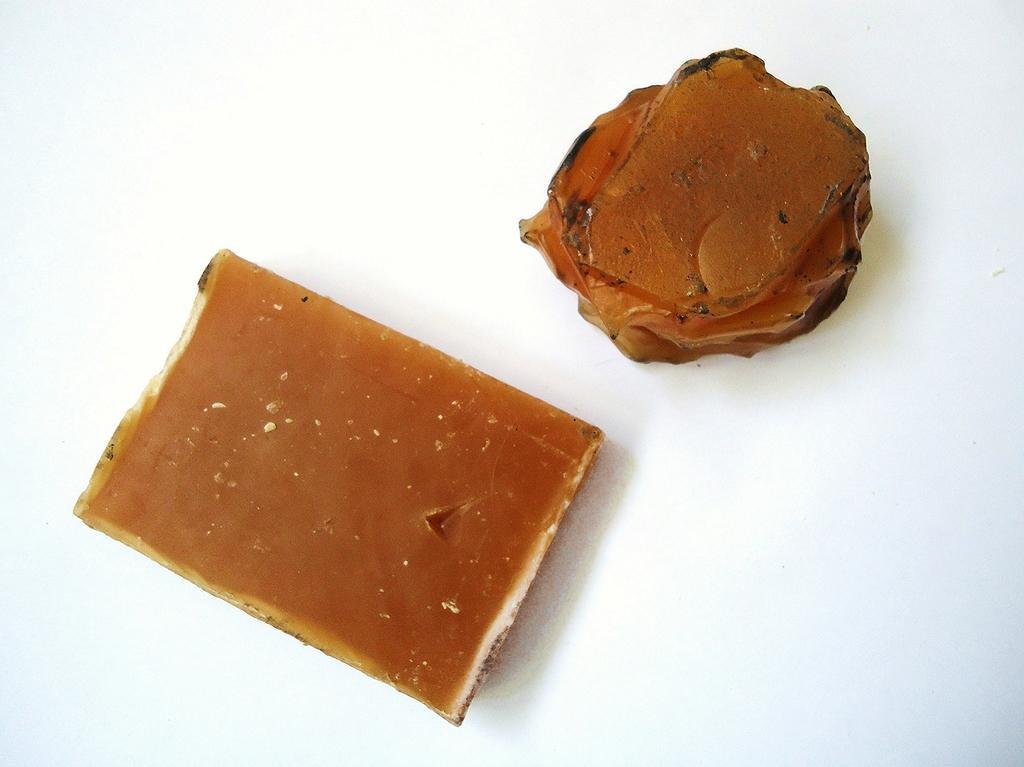Describe this image in one or two sentences. This image consists of two brown color objects with looks like jelly or wax are kept on the floor. 